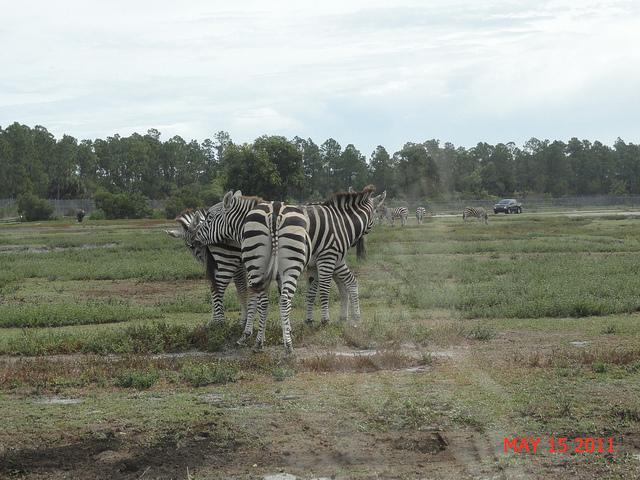What animal is most similar to these? Please explain your reasoning. horse. The animal looks like a horse. 